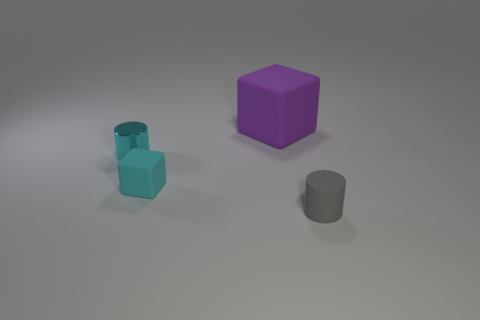Can you describe the colors and shapes of the objects in the image? Certainly! The image depicts three objects, each with a distinct color and shape. On the left, there's a small teal-colored cylinder. In the center, we have a larger purple cube. Finally, on the right, there's a medium-sized gray cylinder. The background is a neutral gray, which sets off the objects' colors nicely. 